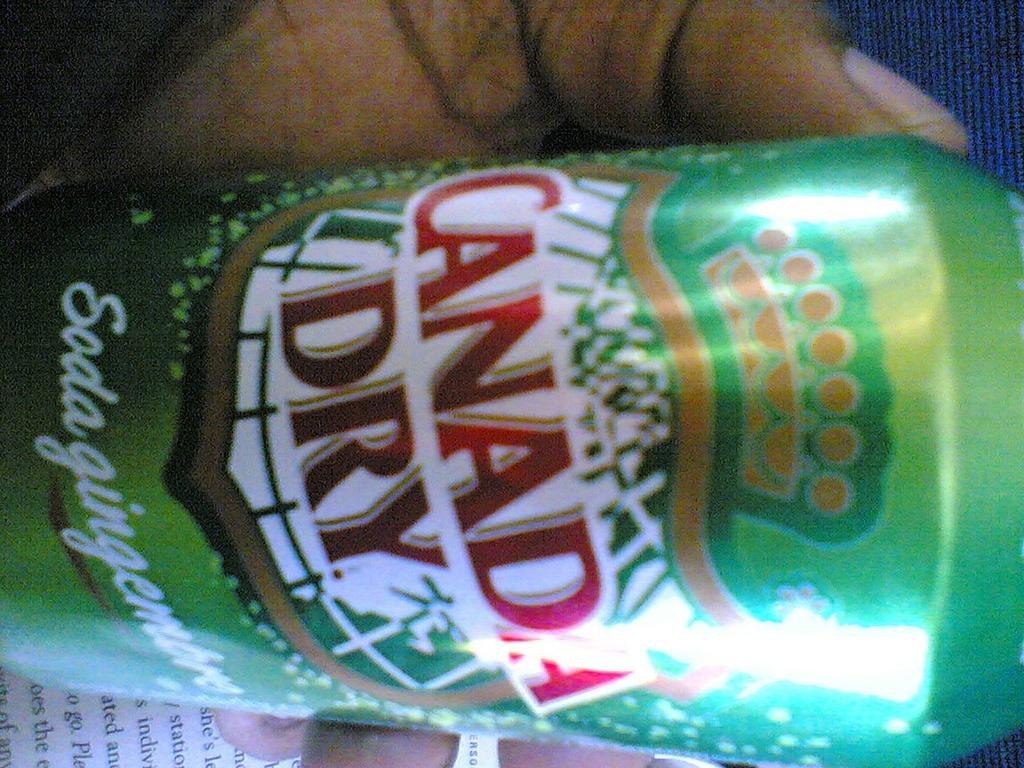Can you describe this image briefly? The picture consists of a person holding a coke tin. At the bottom there is a paper. At the top it is blue jeans. 